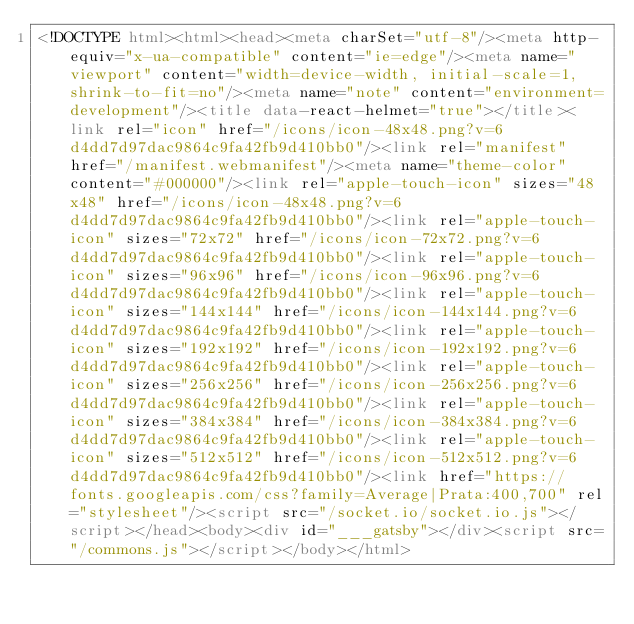Convert code to text. <code><loc_0><loc_0><loc_500><loc_500><_HTML_><!DOCTYPE html><html><head><meta charSet="utf-8"/><meta http-equiv="x-ua-compatible" content="ie=edge"/><meta name="viewport" content="width=device-width, initial-scale=1, shrink-to-fit=no"/><meta name="note" content="environment=development"/><title data-react-helmet="true"></title><link rel="icon" href="/icons/icon-48x48.png?v=6d4dd7d97dac9864c9fa42fb9d410bb0"/><link rel="manifest" href="/manifest.webmanifest"/><meta name="theme-color" content="#000000"/><link rel="apple-touch-icon" sizes="48x48" href="/icons/icon-48x48.png?v=6d4dd7d97dac9864c9fa42fb9d410bb0"/><link rel="apple-touch-icon" sizes="72x72" href="/icons/icon-72x72.png?v=6d4dd7d97dac9864c9fa42fb9d410bb0"/><link rel="apple-touch-icon" sizes="96x96" href="/icons/icon-96x96.png?v=6d4dd7d97dac9864c9fa42fb9d410bb0"/><link rel="apple-touch-icon" sizes="144x144" href="/icons/icon-144x144.png?v=6d4dd7d97dac9864c9fa42fb9d410bb0"/><link rel="apple-touch-icon" sizes="192x192" href="/icons/icon-192x192.png?v=6d4dd7d97dac9864c9fa42fb9d410bb0"/><link rel="apple-touch-icon" sizes="256x256" href="/icons/icon-256x256.png?v=6d4dd7d97dac9864c9fa42fb9d410bb0"/><link rel="apple-touch-icon" sizes="384x384" href="/icons/icon-384x384.png?v=6d4dd7d97dac9864c9fa42fb9d410bb0"/><link rel="apple-touch-icon" sizes="512x512" href="/icons/icon-512x512.png?v=6d4dd7d97dac9864c9fa42fb9d410bb0"/><link href="https://fonts.googleapis.com/css?family=Average|Prata:400,700" rel="stylesheet"/><script src="/socket.io/socket.io.js"></script></head><body><div id="___gatsby"></div><script src="/commons.js"></script></body></html></code> 